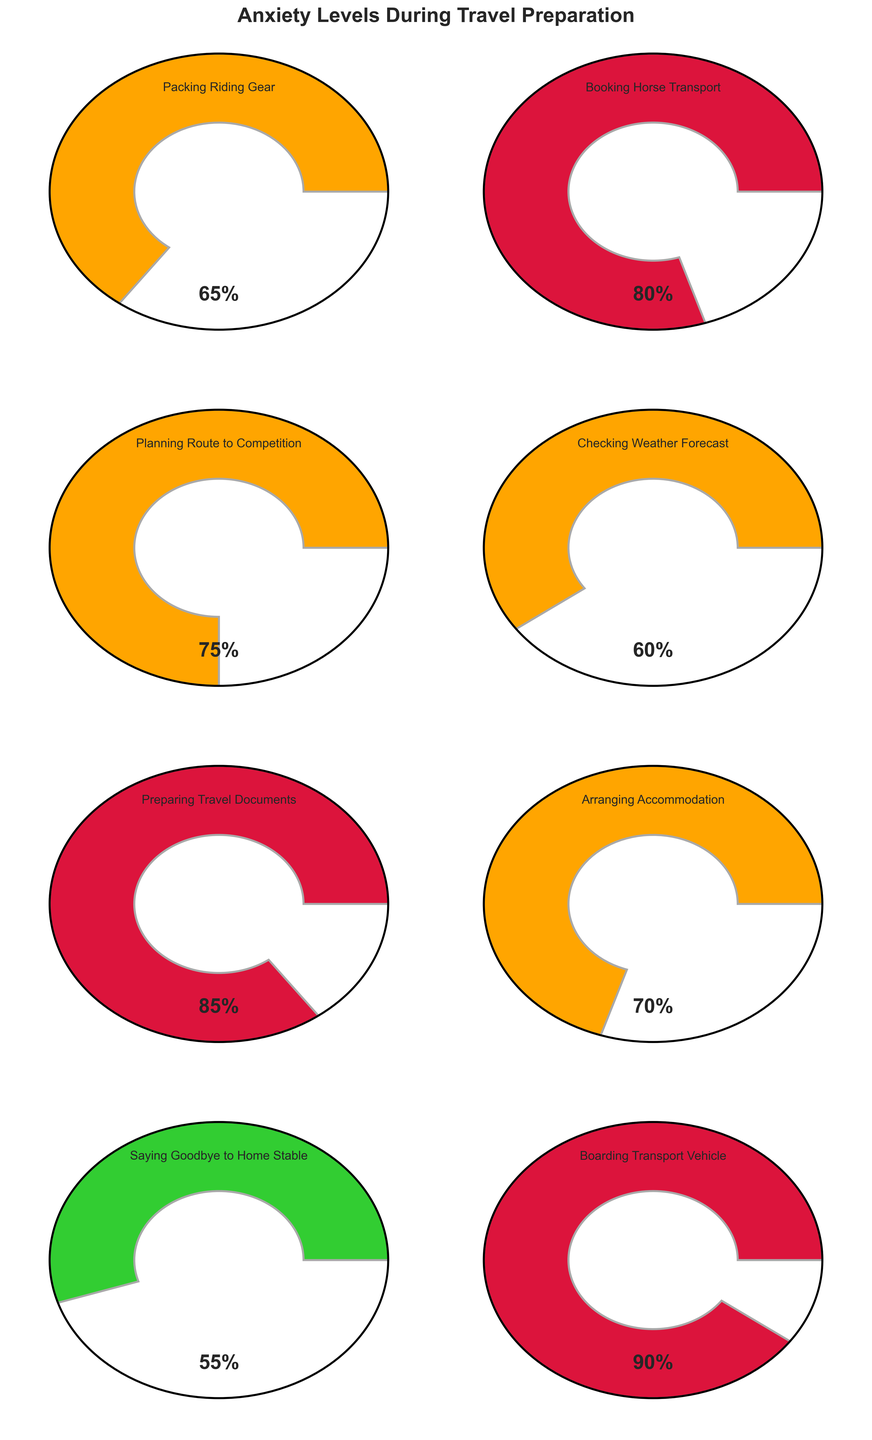What's the highest anxiety level recorded in the figure? The highest anxiety level can be identified by looking at the percentage values displayed on each gauge. The highest recorded anxiety level is shown as 90% on the gauge for "Boarding Transport Vehicle."
Answer: 90% Which stage has the lowest anxiety level? To determine the lowest anxiety level, look at the percentage values on each gauge. The lowest value shown is 55%, which corresponds to "Saying Goodbye to Home Stable."
Answer: Saying Goodbye to Home Stable What is the average anxiety level across all the stages? To calculate the average, sum all the anxiety levels and divide by the number of stages. The sum is (65 + 80 + 75 + 60 + 85 + 70 + 55 + 90) = 580. There are 8 stages, so the average is 580 / 8 = 72.5.
Answer: 72.5 Which stages have anxiety levels greater than 80%? Identify the gauges with values exceeding 80%. These are "Booking Horse Transport" (80%), "Preparing Travel Documents" (85%), and "Boarding Transport Vehicle" (90%).
Answer: Booking Horse Transport, Preparing Travel Documents, Boarding Transport Vehicle How many stages have an anxiety level within the range of 60% to 80%? Count the number of stages where the anxiety level falls between 60% and 80%. These stages are "Packing Riding Gear" (65%), "Planning Route to Competition" (75%), "Arranging Accommodation" (70%), and "Booking Horse Transport" (80%). Since 80 is included, there are 4 stages in total.
Answer: 4 What is the difference in anxiety levels between "Packing Riding Gear" and "Boarding Transport Vehicle"? Subtract the anxiety level of "Packing Riding Gear" from "Boarding Transport Vehicle." The calculation is 90 - 65 = 25.
Answer: 25 In which stages is the anxiety level exactly 75%? Identify the stage where the anxiety level is exactly 75%. This value appears on the gauge for "Planning Route to Competition."
Answer: Planning Route to Competition Which stage has a similar anxiety level to "Arranging Accommodation"? Look for stages with anxiety levels close to 70%, the anxiety level for "Arranging Accommodation." "Packing Riding Gear" has a level of 65%, which is the closest.
Answer: Packing Riding Gear Which stages have anxiety levels marked in orange? Anxiety levels in orange range from 60% to 80%. These stages are "Packing Riding Gear" (65%), "Booking Horse Transport" (80%), "Planning Route to Competition" (75%), and "Arranging Accommodation" (70%).
Answer: Packing Riding Gear, Booking Horse Transport, Planning Route to Competition, Arranging Accommodation 